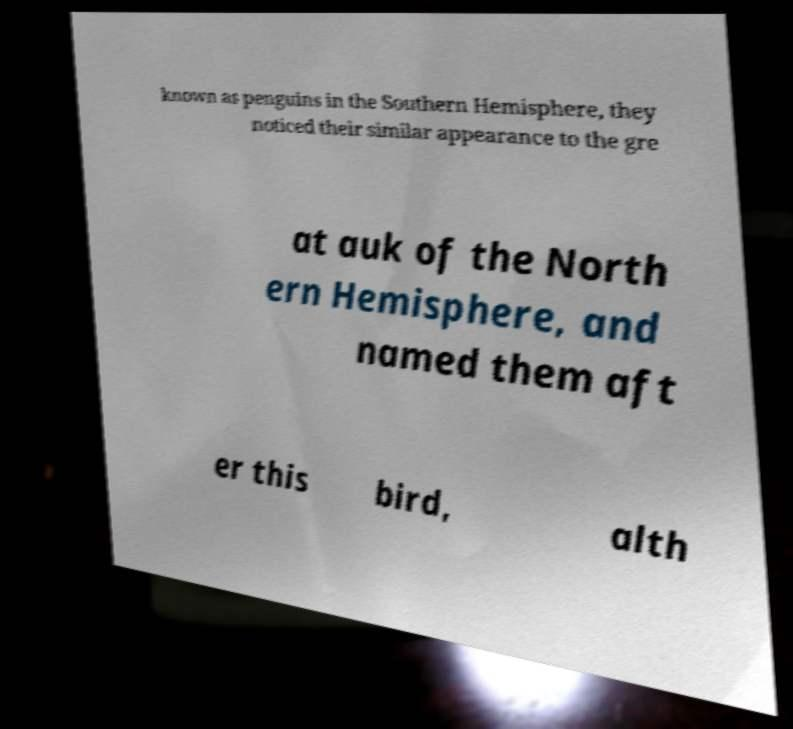Can you accurately transcribe the text from the provided image for me? known as penguins in the Southern Hemisphere, they noticed their similar appearance to the gre at auk of the North ern Hemisphere, and named them aft er this bird, alth 